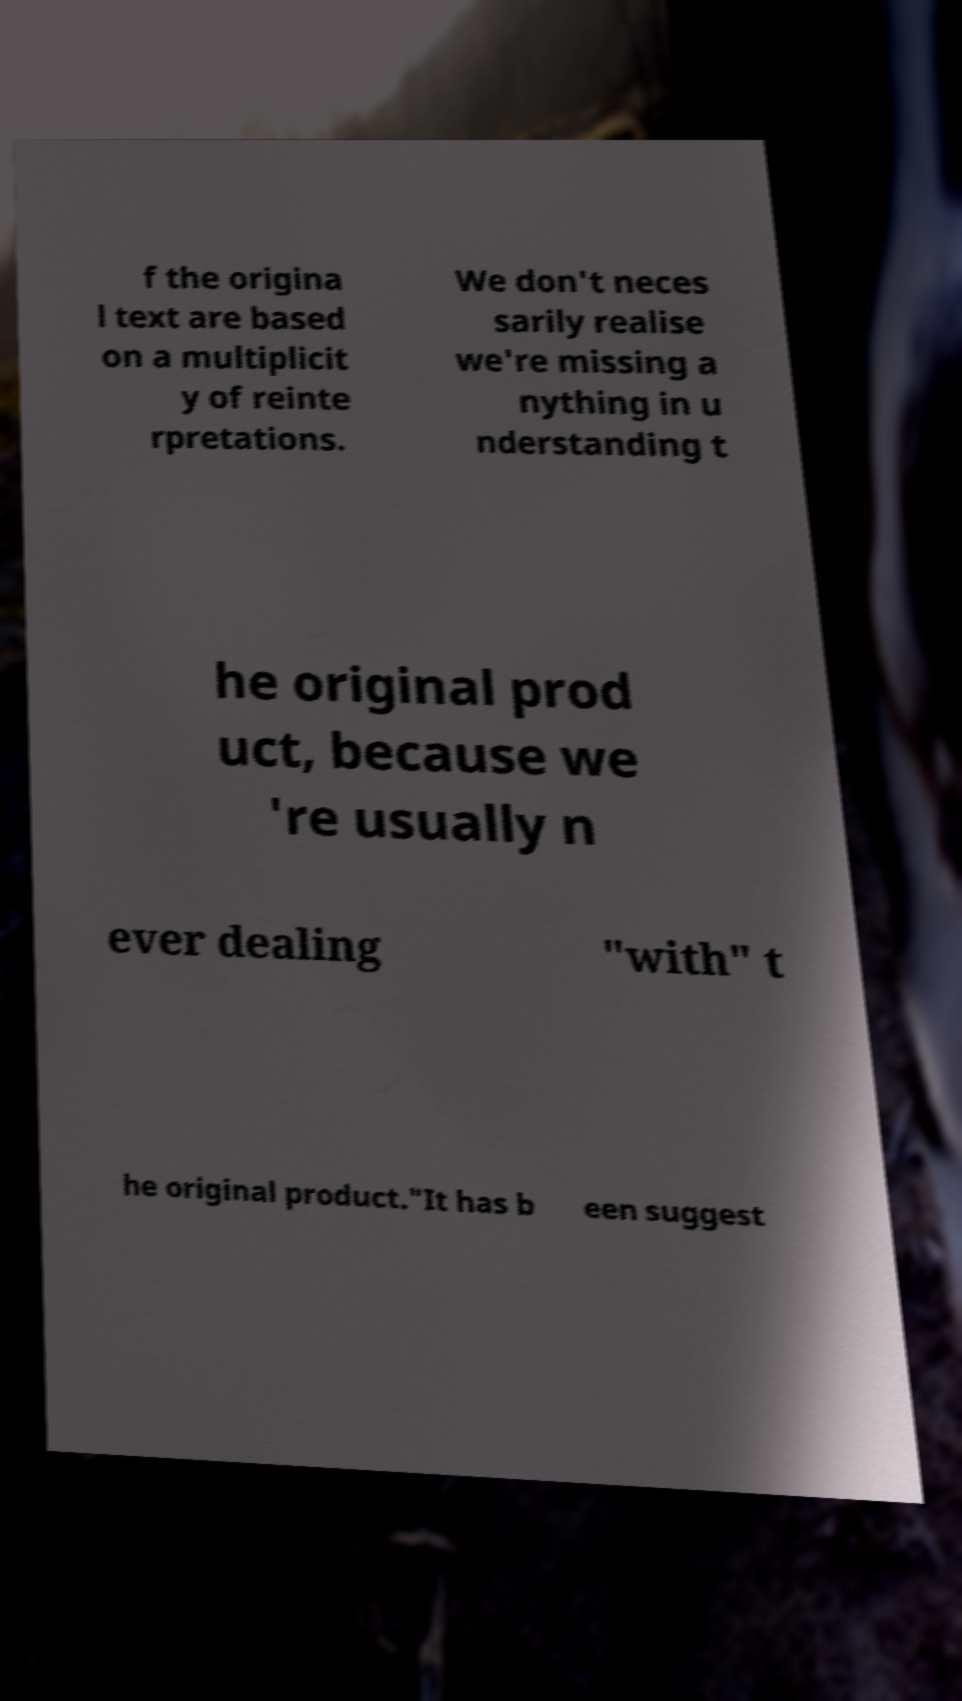Please identify and transcribe the text found in this image. f the origina l text are based on a multiplicit y of reinte rpretations. We don't neces sarily realise we're missing a nything in u nderstanding t he original prod uct, because we 're usually n ever dealing "with" t he original product."It has b een suggest 